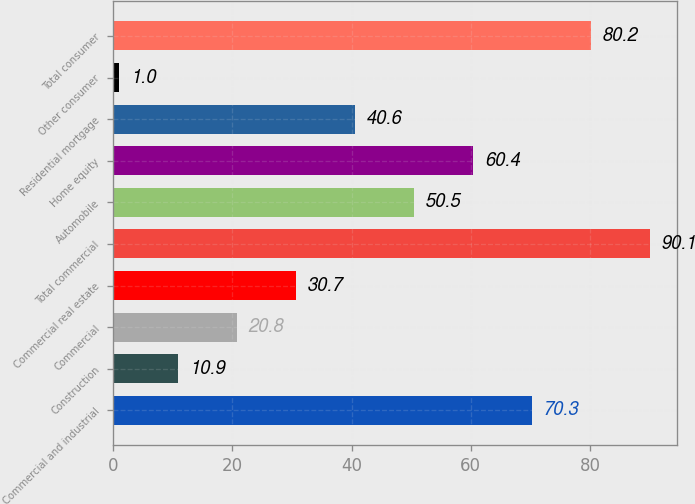<chart> <loc_0><loc_0><loc_500><loc_500><bar_chart><fcel>Commercial and industrial<fcel>Construction<fcel>Commercial<fcel>Commercial real estate<fcel>Total commercial<fcel>Automobile<fcel>Home equity<fcel>Residential mortgage<fcel>Other consumer<fcel>Total consumer<nl><fcel>70.3<fcel>10.9<fcel>20.8<fcel>30.7<fcel>90.1<fcel>50.5<fcel>60.4<fcel>40.6<fcel>1<fcel>80.2<nl></chart> 